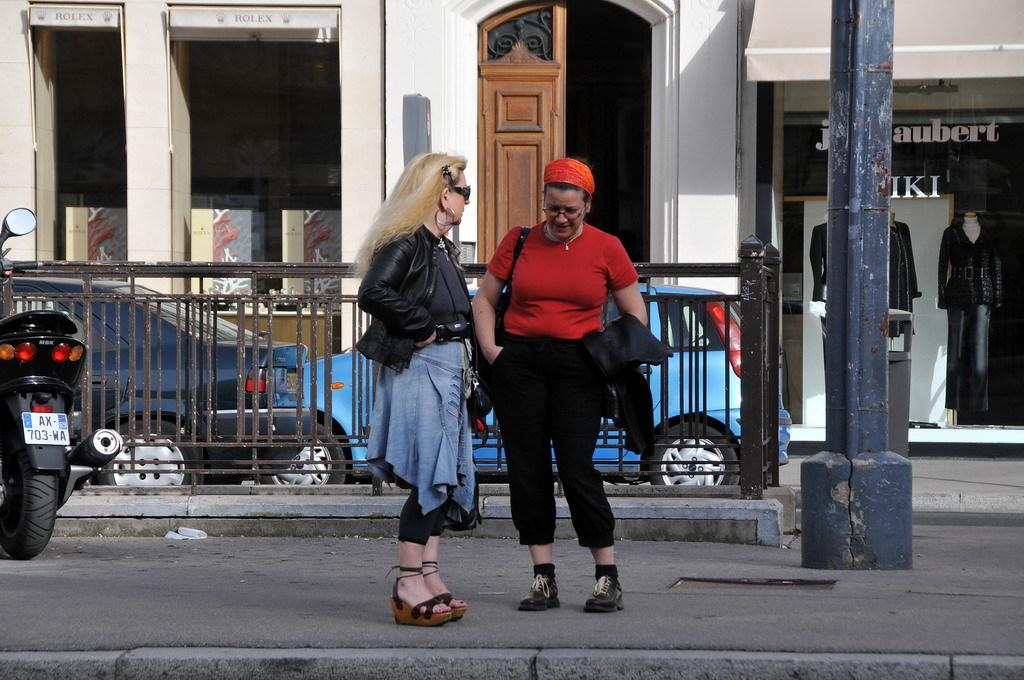What are the people in the image doing? The people in the image are standing on the road. What is located behind the people? There is a fence behind the people. What type of vehicles can be seen in the image? Cars are visible in the image. What can be seen in the distance in the image? There are buildings in the background. What type of acoustics can be heard during the feast in the image? There is no feast present in the image, so it is not possible to determine the acoustics. 